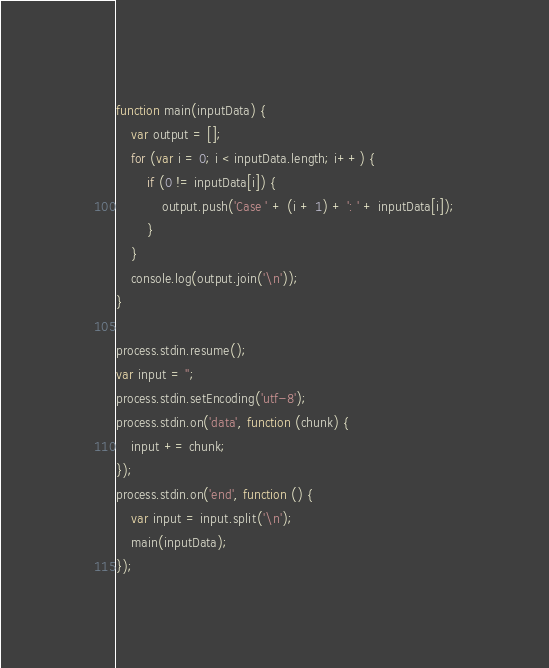Convert code to text. <code><loc_0><loc_0><loc_500><loc_500><_JavaScript_>function main(inputData) {
    var output = [];
    for (var i = 0; i < inputData.length; i++) {
        if (0 != inputData[i]) {
            output.push('Case ' + (i + 1) + ': ' + inputData[i]);
        }
    }
    console.log(output.join('\n'));
}

process.stdin.resume();
var input = '';
process.stdin.setEncoding('utf-8');
process.stdin.on('data', function (chunk) {
    input += chunk;
});
process.stdin.on('end', function () {
    var input = input.split('\n');
    main(inputData);
});</code> 